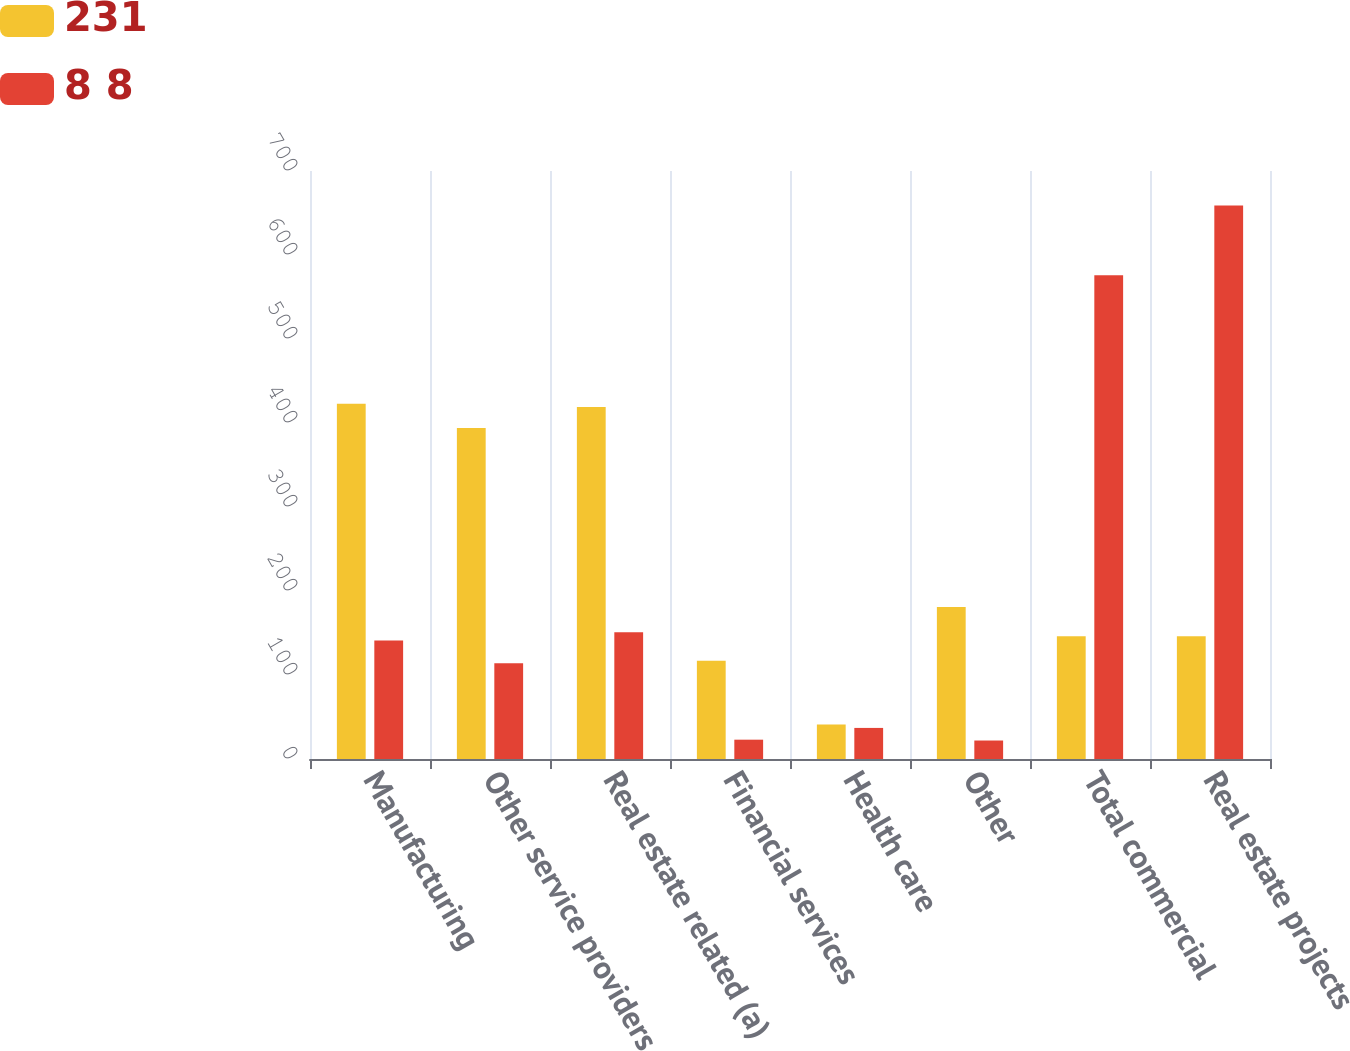Convert chart. <chart><loc_0><loc_0><loc_500><loc_500><stacked_bar_chart><ecel><fcel>Manufacturing<fcel>Other service providers<fcel>Real estate related (a)<fcel>Financial services<fcel>Health care<fcel>Other<fcel>Total commercial<fcel>Real estate projects<nl><fcel>231<fcel>423<fcel>394<fcel>419<fcel>117<fcel>41<fcel>181<fcel>146<fcel>146<nl><fcel>8 8<fcel>141<fcel>114<fcel>151<fcel>23<fcel>37<fcel>22<fcel>576<fcel>659<nl></chart> 